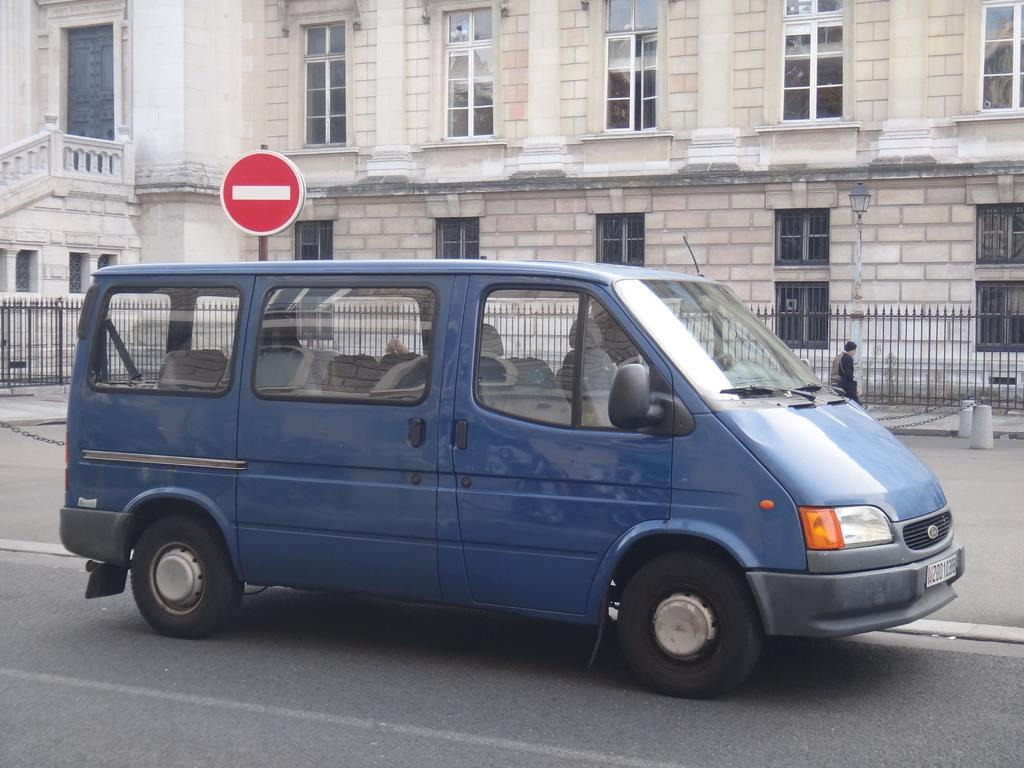What is on the road in the image? There is a vehicle on the road in the image. What is happening beside the road? There is a person walking beside the road. What type of equipment is visible in the image? There is a spine board visible in the image. What type of structure is present in the image? There is a building with windows in the image. What type of badge is the person wearing in the image? There is no information about a badge in the image. How many passengers are in the vehicle in the image? There is no information about the number of passengers in the vehicle in the image. What type of loaf is being carried by the person walking beside the road? There is no loaf present in the image. 